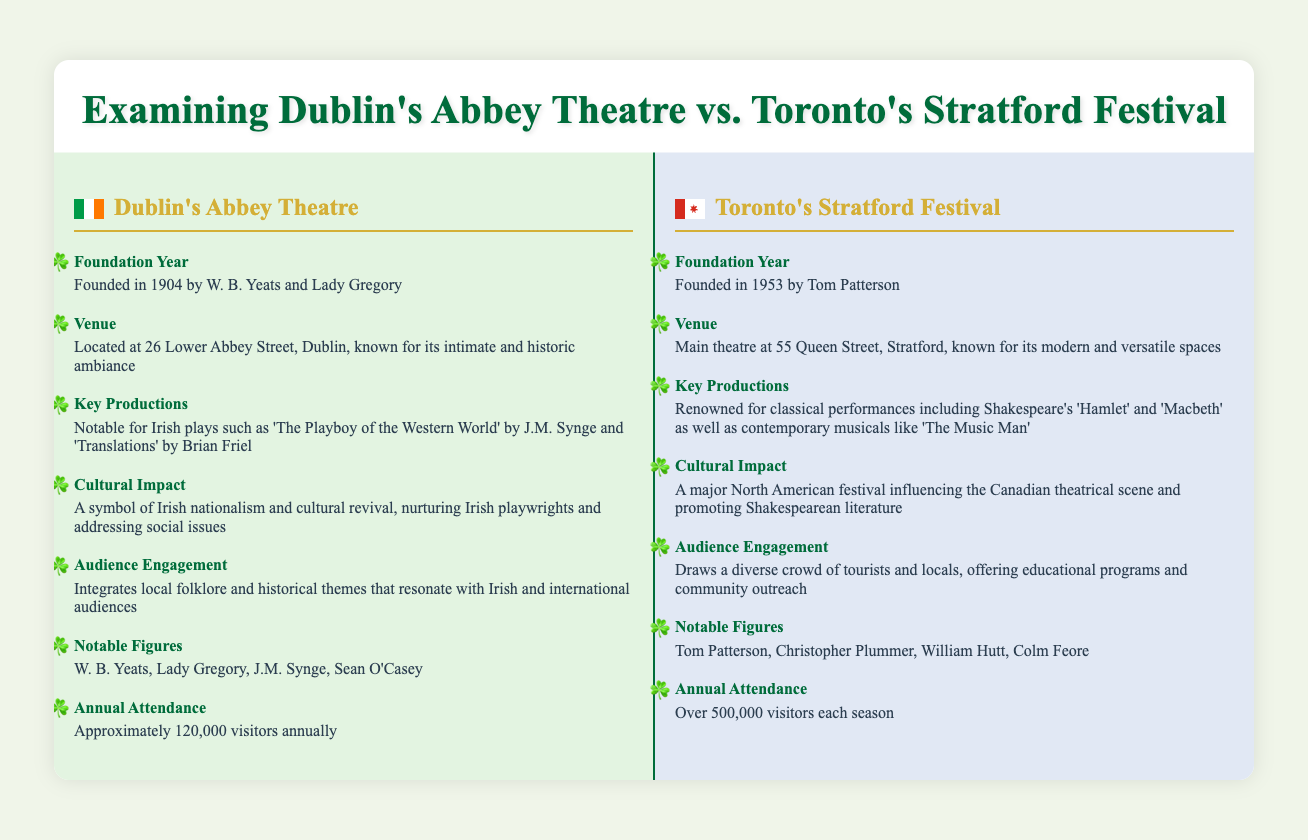what year was Dublin's Abbey Theatre founded? The foundation year of Dublin's Abbey Theatre is explicitly mentioned in the document.
Answer: 1904 what is the annual attendance of the Stratford Festival? The annual attendance figure for the Stratford Festival is provided in the document, highlighting its popularity.
Answer: Over 500,000 visitors each season who founded Dublin's Abbey Theatre? The document states that W. B. Yeats and Lady Gregory founded the Abbey Theatre.
Answer: W. B. Yeats and Lady Gregory what is the key production associated with Dublin's Abbey Theatre? The document lists notable productions for the Abbey Theatre, focusing on significant Irish plays.
Answer: 'The Playboy of the Western World' what is a notable figure of the Stratford Festival? The document lists key contributors to the Stratford Festival, helping to identify its influential figures.
Answer: Colm Feore what type of ambiance is associated with Dublin's Abbey Theatre? The document describes the Abbey Theatre's venue, focusing on its characteristics.
Answer: Intimate and historic ambiance how does the Abbey Theatre engage its audience? The document mentions specific themes and folklore that the Abbey Theatre integrates into its productions for audience engagement.
Answer: Local folklore and historical themes what cultural impact does the Stratford Festival have? The document outlines the cultural significance of the Stratford Festival in the context of North American theatre.
Answer: Influencing the Canadian theatrical scene which year did the Stratford Festival begin? The foundation year of the Stratford Festival is clearly stated in the information provided.
Answer: 1953 